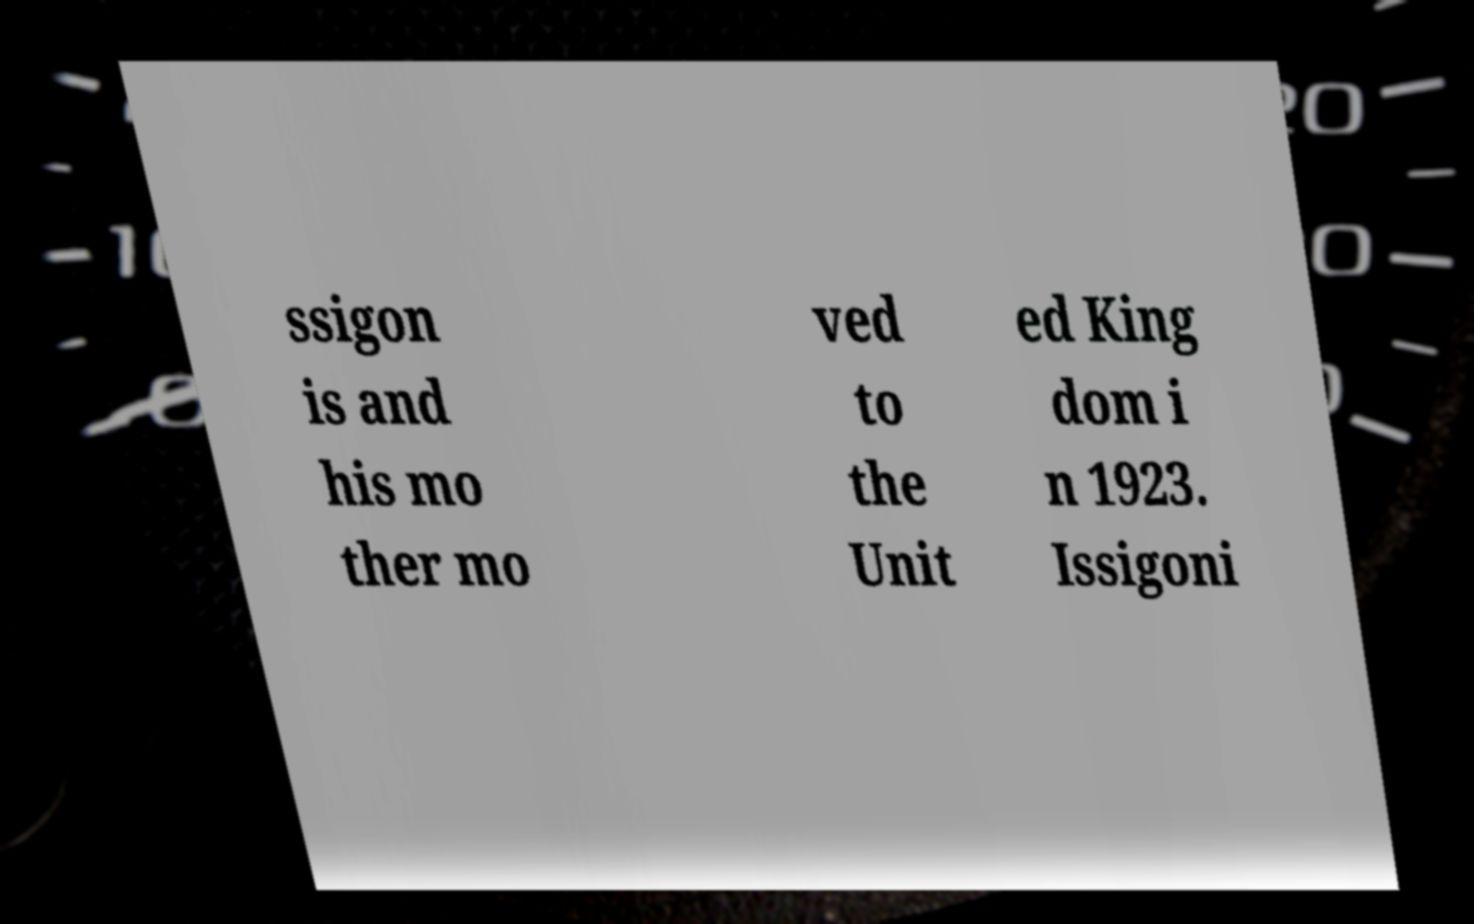Please read and relay the text visible in this image. What does it say? ssigon is and his mo ther mo ved to the Unit ed King dom i n 1923. Issigoni 